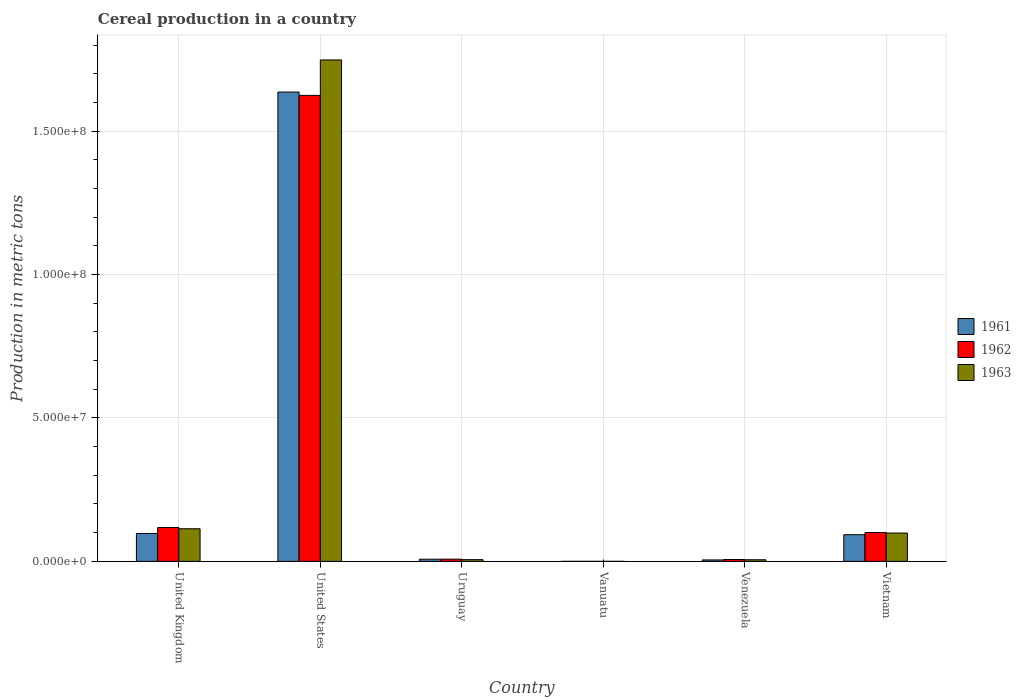How many different coloured bars are there?
Provide a short and direct response. 3. How many groups of bars are there?
Offer a very short reply. 6. Are the number of bars per tick equal to the number of legend labels?
Make the answer very short. Yes. How many bars are there on the 4th tick from the left?
Your answer should be very brief. 3. What is the label of the 3rd group of bars from the left?
Offer a terse response. Uruguay. In how many cases, is the number of bars for a given country not equal to the number of legend labels?
Give a very brief answer. 0. What is the total cereal production in 1961 in Uruguay?
Ensure brevity in your answer.  7.51e+05. Across all countries, what is the maximum total cereal production in 1961?
Keep it short and to the point. 1.64e+08. Across all countries, what is the minimum total cereal production in 1963?
Your answer should be compact. 350. In which country was the total cereal production in 1962 maximum?
Keep it short and to the point. United States. In which country was the total cereal production in 1962 minimum?
Offer a terse response. Vanuatu. What is the total total cereal production in 1961 in the graph?
Your response must be concise. 1.84e+08. What is the difference between the total cereal production in 1963 in Uruguay and that in Venezuela?
Ensure brevity in your answer.  3.44e+04. What is the difference between the total cereal production in 1961 in United Kingdom and the total cereal production in 1962 in Vietnam?
Offer a terse response. -3.39e+05. What is the average total cereal production in 1963 per country?
Keep it short and to the point. 3.29e+07. What is the difference between the total cereal production of/in 1963 and total cereal production of/in 1962 in Uruguay?
Provide a succinct answer. -1.68e+05. In how many countries, is the total cereal production in 1962 greater than 150000000 metric tons?
Provide a succinct answer. 1. What is the ratio of the total cereal production in 1963 in United Kingdom to that in Venezuela?
Provide a short and direct response. 20.21. Is the difference between the total cereal production in 1963 in United Kingdom and United States greater than the difference between the total cereal production in 1962 in United Kingdom and United States?
Offer a terse response. No. What is the difference between the highest and the second highest total cereal production in 1963?
Offer a terse response. 1.49e+06. What is the difference between the highest and the lowest total cereal production in 1963?
Your response must be concise. 1.75e+08. Are all the bars in the graph horizontal?
Offer a terse response. No. What is the difference between two consecutive major ticks on the Y-axis?
Keep it short and to the point. 5.00e+07. Are the values on the major ticks of Y-axis written in scientific E-notation?
Offer a terse response. Yes. Does the graph contain any zero values?
Provide a succinct answer. No. Does the graph contain grids?
Your response must be concise. Yes. Where does the legend appear in the graph?
Your answer should be compact. Center right. How many legend labels are there?
Ensure brevity in your answer.  3. How are the legend labels stacked?
Your answer should be compact. Vertical. What is the title of the graph?
Provide a short and direct response. Cereal production in a country. What is the label or title of the Y-axis?
Make the answer very short. Production in metric tons. What is the Production in metric tons in 1961 in United Kingdom?
Provide a short and direct response. 9.72e+06. What is the Production in metric tons in 1962 in United Kingdom?
Your response must be concise. 1.18e+07. What is the Production in metric tons of 1963 in United Kingdom?
Your answer should be very brief. 1.14e+07. What is the Production in metric tons in 1961 in United States?
Your answer should be compact. 1.64e+08. What is the Production in metric tons in 1962 in United States?
Make the answer very short. 1.62e+08. What is the Production in metric tons of 1963 in United States?
Your answer should be compact. 1.75e+08. What is the Production in metric tons in 1961 in Uruguay?
Keep it short and to the point. 7.51e+05. What is the Production in metric tons of 1962 in Uruguay?
Your answer should be very brief. 7.65e+05. What is the Production in metric tons of 1963 in Uruguay?
Your answer should be compact. 5.97e+05. What is the Production in metric tons in 1961 in Vanuatu?
Keep it short and to the point. 350. What is the Production in metric tons in 1962 in Vanuatu?
Your response must be concise. 350. What is the Production in metric tons in 1963 in Vanuatu?
Your answer should be compact. 350. What is the Production in metric tons of 1961 in Venezuela?
Ensure brevity in your answer.  5.01e+05. What is the Production in metric tons in 1962 in Venezuela?
Provide a succinct answer. 6.44e+05. What is the Production in metric tons in 1963 in Venezuela?
Provide a short and direct response. 5.62e+05. What is the Production in metric tons of 1961 in Vietnam?
Make the answer very short. 9.29e+06. What is the Production in metric tons of 1962 in Vietnam?
Give a very brief answer. 1.01e+07. What is the Production in metric tons in 1963 in Vietnam?
Make the answer very short. 9.88e+06. Across all countries, what is the maximum Production in metric tons of 1961?
Provide a short and direct response. 1.64e+08. Across all countries, what is the maximum Production in metric tons of 1962?
Keep it short and to the point. 1.62e+08. Across all countries, what is the maximum Production in metric tons of 1963?
Your response must be concise. 1.75e+08. Across all countries, what is the minimum Production in metric tons of 1961?
Ensure brevity in your answer.  350. Across all countries, what is the minimum Production in metric tons of 1962?
Your answer should be compact. 350. Across all countries, what is the minimum Production in metric tons of 1963?
Your response must be concise. 350. What is the total Production in metric tons of 1961 in the graph?
Keep it short and to the point. 1.84e+08. What is the total Production in metric tons in 1962 in the graph?
Your answer should be compact. 1.86e+08. What is the total Production in metric tons in 1963 in the graph?
Provide a short and direct response. 1.97e+08. What is the difference between the Production in metric tons of 1961 in United Kingdom and that in United States?
Your response must be concise. -1.54e+08. What is the difference between the Production in metric tons in 1962 in United Kingdom and that in United States?
Provide a short and direct response. -1.51e+08. What is the difference between the Production in metric tons of 1963 in United Kingdom and that in United States?
Your answer should be very brief. -1.63e+08. What is the difference between the Production in metric tons of 1961 in United Kingdom and that in Uruguay?
Provide a succinct answer. 8.97e+06. What is the difference between the Production in metric tons of 1962 in United Kingdom and that in Uruguay?
Offer a very short reply. 1.10e+07. What is the difference between the Production in metric tons in 1963 in United Kingdom and that in Uruguay?
Provide a succinct answer. 1.08e+07. What is the difference between the Production in metric tons in 1961 in United Kingdom and that in Vanuatu?
Your answer should be very brief. 9.72e+06. What is the difference between the Production in metric tons of 1962 in United Kingdom and that in Vanuatu?
Give a very brief answer. 1.18e+07. What is the difference between the Production in metric tons in 1963 in United Kingdom and that in Vanuatu?
Your answer should be very brief. 1.14e+07. What is the difference between the Production in metric tons in 1961 in United Kingdom and that in Venezuela?
Provide a short and direct response. 9.22e+06. What is the difference between the Production in metric tons in 1962 in United Kingdom and that in Venezuela?
Offer a very short reply. 1.11e+07. What is the difference between the Production in metric tons of 1963 in United Kingdom and that in Venezuela?
Provide a short and direct response. 1.08e+07. What is the difference between the Production in metric tons in 1961 in United Kingdom and that in Vietnam?
Keep it short and to the point. 4.32e+05. What is the difference between the Production in metric tons in 1962 in United Kingdom and that in Vietnam?
Provide a succinct answer. 1.73e+06. What is the difference between the Production in metric tons of 1963 in United Kingdom and that in Vietnam?
Offer a very short reply. 1.49e+06. What is the difference between the Production in metric tons in 1961 in United States and that in Uruguay?
Ensure brevity in your answer.  1.63e+08. What is the difference between the Production in metric tons of 1962 in United States and that in Uruguay?
Make the answer very short. 1.62e+08. What is the difference between the Production in metric tons in 1963 in United States and that in Uruguay?
Provide a succinct answer. 1.74e+08. What is the difference between the Production in metric tons in 1961 in United States and that in Vanuatu?
Keep it short and to the point. 1.64e+08. What is the difference between the Production in metric tons in 1962 in United States and that in Vanuatu?
Ensure brevity in your answer.  1.62e+08. What is the difference between the Production in metric tons in 1963 in United States and that in Vanuatu?
Your response must be concise. 1.75e+08. What is the difference between the Production in metric tons in 1961 in United States and that in Venezuela?
Your response must be concise. 1.63e+08. What is the difference between the Production in metric tons in 1962 in United States and that in Venezuela?
Provide a succinct answer. 1.62e+08. What is the difference between the Production in metric tons in 1963 in United States and that in Venezuela?
Your response must be concise. 1.74e+08. What is the difference between the Production in metric tons in 1961 in United States and that in Vietnam?
Your answer should be compact. 1.54e+08. What is the difference between the Production in metric tons of 1962 in United States and that in Vietnam?
Give a very brief answer. 1.52e+08. What is the difference between the Production in metric tons of 1963 in United States and that in Vietnam?
Your answer should be very brief. 1.65e+08. What is the difference between the Production in metric tons of 1961 in Uruguay and that in Vanuatu?
Provide a short and direct response. 7.51e+05. What is the difference between the Production in metric tons of 1962 in Uruguay and that in Vanuatu?
Give a very brief answer. 7.64e+05. What is the difference between the Production in metric tons in 1963 in Uruguay and that in Vanuatu?
Ensure brevity in your answer.  5.96e+05. What is the difference between the Production in metric tons in 1961 in Uruguay and that in Venezuela?
Offer a very short reply. 2.50e+05. What is the difference between the Production in metric tons in 1962 in Uruguay and that in Venezuela?
Provide a short and direct response. 1.20e+05. What is the difference between the Production in metric tons of 1963 in Uruguay and that in Venezuela?
Your answer should be compact. 3.44e+04. What is the difference between the Production in metric tons of 1961 in Uruguay and that in Vietnam?
Provide a short and direct response. -8.54e+06. What is the difference between the Production in metric tons of 1962 in Uruguay and that in Vietnam?
Make the answer very short. -9.30e+06. What is the difference between the Production in metric tons of 1963 in Uruguay and that in Vietnam?
Offer a very short reply. -9.28e+06. What is the difference between the Production in metric tons in 1961 in Vanuatu and that in Venezuela?
Give a very brief answer. -5.01e+05. What is the difference between the Production in metric tons of 1962 in Vanuatu and that in Venezuela?
Your answer should be compact. -6.44e+05. What is the difference between the Production in metric tons in 1963 in Vanuatu and that in Venezuela?
Provide a succinct answer. -5.62e+05. What is the difference between the Production in metric tons in 1961 in Vanuatu and that in Vietnam?
Your response must be concise. -9.29e+06. What is the difference between the Production in metric tons of 1962 in Vanuatu and that in Vietnam?
Provide a succinct answer. -1.01e+07. What is the difference between the Production in metric tons in 1963 in Vanuatu and that in Vietnam?
Offer a very short reply. -9.88e+06. What is the difference between the Production in metric tons of 1961 in Venezuela and that in Vietnam?
Keep it short and to the point. -8.79e+06. What is the difference between the Production in metric tons of 1962 in Venezuela and that in Vietnam?
Make the answer very short. -9.42e+06. What is the difference between the Production in metric tons of 1963 in Venezuela and that in Vietnam?
Your response must be concise. -9.31e+06. What is the difference between the Production in metric tons in 1961 in United Kingdom and the Production in metric tons in 1962 in United States?
Make the answer very short. -1.53e+08. What is the difference between the Production in metric tons of 1961 in United Kingdom and the Production in metric tons of 1963 in United States?
Your answer should be compact. -1.65e+08. What is the difference between the Production in metric tons in 1962 in United Kingdom and the Production in metric tons in 1963 in United States?
Ensure brevity in your answer.  -1.63e+08. What is the difference between the Production in metric tons in 1961 in United Kingdom and the Production in metric tons in 1962 in Uruguay?
Offer a very short reply. 8.96e+06. What is the difference between the Production in metric tons in 1961 in United Kingdom and the Production in metric tons in 1963 in Uruguay?
Offer a very short reply. 9.13e+06. What is the difference between the Production in metric tons in 1962 in United Kingdom and the Production in metric tons in 1963 in Uruguay?
Give a very brief answer. 1.12e+07. What is the difference between the Production in metric tons of 1961 in United Kingdom and the Production in metric tons of 1962 in Vanuatu?
Your response must be concise. 9.72e+06. What is the difference between the Production in metric tons in 1961 in United Kingdom and the Production in metric tons in 1963 in Vanuatu?
Ensure brevity in your answer.  9.72e+06. What is the difference between the Production in metric tons of 1962 in United Kingdom and the Production in metric tons of 1963 in Vanuatu?
Your answer should be very brief. 1.18e+07. What is the difference between the Production in metric tons in 1961 in United Kingdom and the Production in metric tons in 1962 in Venezuela?
Ensure brevity in your answer.  9.08e+06. What is the difference between the Production in metric tons of 1961 in United Kingdom and the Production in metric tons of 1963 in Venezuela?
Offer a terse response. 9.16e+06. What is the difference between the Production in metric tons in 1962 in United Kingdom and the Production in metric tons in 1963 in Venezuela?
Keep it short and to the point. 1.12e+07. What is the difference between the Production in metric tons in 1961 in United Kingdom and the Production in metric tons in 1962 in Vietnam?
Provide a short and direct response. -3.39e+05. What is the difference between the Production in metric tons in 1961 in United Kingdom and the Production in metric tons in 1963 in Vietnam?
Give a very brief answer. -1.55e+05. What is the difference between the Production in metric tons in 1962 in United Kingdom and the Production in metric tons in 1963 in Vietnam?
Give a very brief answer. 1.91e+06. What is the difference between the Production in metric tons in 1961 in United States and the Production in metric tons in 1962 in Uruguay?
Provide a succinct answer. 1.63e+08. What is the difference between the Production in metric tons in 1961 in United States and the Production in metric tons in 1963 in Uruguay?
Make the answer very short. 1.63e+08. What is the difference between the Production in metric tons of 1962 in United States and the Production in metric tons of 1963 in Uruguay?
Offer a terse response. 1.62e+08. What is the difference between the Production in metric tons in 1961 in United States and the Production in metric tons in 1962 in Vanuatu?
Provide a short and direct response. 1.64e+08. What is the difference between the Production in metric tons in 1961 in United States and the Production in metric tons in 1963 in Vanuatu?
Provide a short and direct response. 1.64e+08. What is the difference between the Production in metric tons in 1962 in United States and the Production in metric tons in 1963 in Vanuatu?
Make the answer very short. 1.62e+08. What is the difference between the Production in metric tons in 1961 in United States and the Production in metric tons in 1962 in Venezuela?
Make the answer very short. 1.63e+08. What is the difference between the Production in metric tons in 1961 in United States and the Production in metric tons in 1963 in Venezuela?
Your response must be concise. 1.63e+08. What is the difference between the Production in metric tons of 1962 in United States and the Production in metric tons of 1963 in Venezuela?
Give a very brief answer. 1.62e+08. What is the difference between the Production in metric tons of 1961 in United States and the Production in metric tons of 1962 in Vietnam?
Offer a very short reply. 1.54e+08. What is the difference between the Production in metric tons in 1961 in United States and the Production in metric tons in 1963 in Vietnam?
Your response must be concise. 1.54e+08. What is the difference between the Production in metric tons of 1962 in United States and the Production in metric tons of 1963 in Vietnam?
Make the answer very short. 1.53e+08. What is the difference between the Production in metric tons in 1961 in Uruguay and the Production in metric tons in 1962 in Vanuatu?
Your answer should be compact. 7.51e+05. What is the difference between the Production in metric tons of 1961 in Uruguay and the Production in metric tons of 1963 in Vanuatu?
Your answer should be very brief. 7.51e+05. What is the difference between the Production in metric tons in 1962 in Uruguay and the Production in metric tons in 1963 in Vanuatu?
Your answer should be compact. 7.64e+05. What is the difference between the Production in metric tons in 1961 in Uruguay and the Production in metric tons in 1962 in Venezuela?
Make the answer very short. 1.07e+05. What is the difference between the Production in metric tons of 1961 in Uruguay and the Production in metric tons of 1963 in Venezuela?
Offer a terse response. 1.89e+05. What is the difference between the Production in metric tons in 1962 in Uruguay and the Production in metric tons in 1963 in Venezuela?
Offer a very short reply. 2.02e+05. What is the difference between the Production in metric tons of 1961 in Uruguay and the Production in metric tons of 1962 in Vietnam?
Offer a terse response. -9.31e+06. What is the difference between the Production in metric tons of 1961 in Uruguay and the Production in metric tons of 1963 in Vietnam?
Keep it short and to the point. -9.13e+06. What is the difference between the Production in metric tons of 1962 in Uruguay and the Production in metric tons of 1963 in Vietnam?
Make the answer very short. -9.11e+06. What is the difference between the Production in metric tons in 1961 in Vanuatu and the Production in metric tons in 1962 in Venezuela?
Offer a very short reply. -6.44e+05. What is the difference between the Production in metric tons in 1961 in Vanuatu and the Production in metric tons in 1963 in Venezuela?
Offer a very short reply. -5.62e+05. What is the difference between the Production in metric tons in 1962 in Vanuatu and the Production in metric tons in 1963 in Venezuela?
Ensure brevity in your answer.  -5.62e+05. What is the difference between the Production in metric tons of 1961 in Vanuatu and the Production in metric tons of 1962 in Vietnam?
Offer a terse response. -1.01e+07. What is the difference between the Production in metric tons of 1961 in Vanuatu and the Production in metric tons of 1963 in Vietnam?
Offer a terse response. -9.88e+06. What is the difference between the Production in metric tons of 1962 in Vanuatu and the Production in metric tons of 1963 in Vietnam?
Your response must be concise. -9.88e+06. What is the difference between the Production in metric tons in 1961 in Venezuela and the Production in metric tons in 1962 in Vietnam?
Ensure brevity in your answer.  -9.56e+06. What is the difference between the Production in metric tons of 1961 in Venezuela and the Production in metric tons of 1963 in Vietnam?
Your answer should be very brief. -9.38e+06. What is the difference between the Production in metric tons in 1962 in Venezuela and the Production in metric tons in 1963 in Vietnam?
Your answer should be very brief. -9.23e+06. What is the average Production in metric tons in 1961 per country?
Your answer should be compact. 3.06e+07. What is the average Production in metric tons of 1962 per country?
Your answer should be very brief. 3.10e+07. What is the average Production in metric tons in 1963 per country?
Provide a succinct answer. 3.29e+07. What is the difference between the Production in metric tons of 1961 and Production in metric tons of 1962 in United Kingdom?
Offer a very short reply. -2.07e+06. What is the difference between the Production in metric tons of 1961 and Production in metric tons of 1963 in United Kingdom?
Your response must be concise. -1.64e+06. What is the difference between the Production in metric tons of 1962 and Production in metric tons of 1963 in United Kingdom?
Your response must be concise. 4.26e+05. What is the difference between the Production in metric tons of 1961 and Production in metric tons of 1962 in United States?
Provide a short and direct response. 1.16e+06. What is the difference between the Production in metric tons of 1961 and Production in metric tons of 1963 in United States?
Provide a short and direct response. -1.12e+07. What is the difference between the Production in metric tons of 1962 and Production in metric tons of 1963 in United States?
Your answer should be very brief. -1.24e+07. What is the difference between the Production in metric tons in 1961 and Production in metric tons in 1962 in Uruguay?
Your response must be concise. -1.37e+04. What is the difference between the Production in metric tons of 1961 and Production in metric tons of 1963 in Uruguay?
Your response must be concise. 1.54e+05. What is the difference between the Production in metric tons of 1962 and Production in metric tons of 1963 in Uruguay?
Provide a succinct answer. 1.68e+05. What is the difference between the Production in metric tons in 1961 and Production in metric tons in 1963 in Vanuatu?
Ensure brevity in your answer.  0. What is the difference between the Production in metric tons of 1961 and Production in metric tons of 1962 in Venezuela?
Offer a terse response. -1.43e+05. What is the difference between the Production in metric tons in 1961 and Production in metric tons in 1963 in Venezuela?
Provide a succinct answer. -6.10e+04. What is the difference between the Production in metric tons in 1962 and Production in metric tons in 1963 in Venezuela?
Offer a very short reply. 8.18e+04. What is the difference between the Production in metric tons of 1961 and Production in metric tons of 1962 in Vietnam?
Give a very brief answer. -7.72e+05. What is the difference between the Production in metric tons in 1961 and Production in metric tons in 1963 in Vietnam?
Keep it short and to the point. -5.87e+05. What is the difference between the Production in metric tons of 1962 and Production in metric tons of 1963 in Vietnam?
Offer a terse response. 1.85e+05. What is the ratio of the Production in metric tons of 1961 in United Kingdom to that in United States?
Your answer should be compact. 0.06. What is the ratio of the Production in metric tons in 1962 in United Kingdom to that in United States?
Offer a very short reply. 0.07. What is the ratio of the Production in metric tons of 1963 in United Kingdom to that in United States?
Keep it short and to the point. 0.07. What is the ratio of the Production in metric tons in 1961 in United Kingdom to that in Uruguay?
Your answer should be compact. 12.95. What is the ratio of the Production in metric tons of 1962 in United Kingdom to that in Uruguay?
Make the answer very short. 15.42. What is the ratio of the Production in metric tons in 1963 in United Kingdom to that in Uruguay?
Your answer should be compact. 19.04. What is the ratio of the Production in metric tons of 1961 in United Kingdom to that in Vanuatu?
Provide a short and direct response. 2.78e+04. What is the ratio of the Production in metric tons in 1962 in United Kingdom to that in Vanuatu?
Offer a terse response. 3.37e+04. What is the ratio of the Production in metric tons of 1963 in United Kingdom to that in Vanuatu?
Offer a very short reply. 3.25e+04. What is the ratio of the Production in metric tons in 1961 in United Kingdom to that in Venezuela?
Make the answer very short. 19.39. What is the ratio of the Production in metric tons of 1962 in United Kingdom to that in Venezuela?
Your answer should be compact. 18.3. What is the ratio of the Production in metric tons in 1963 in United Kingdom to that in Venezuela?
Ensure brevity in your answer.  20.21. What is the ratio of the Production in metric tons in 1961 in United Kingdom to that in Vietnam?
Keep it short and to the point. 1.05. What is the ratio of the Production in metric tons of 1962 in United Kingdom to that in Vietnam?
Provide a succinct answer. 1.17. What is the ratio of the Production in metric tons of 1963 in United Kingdom to that in Vietnam?
Provide a succinct answer. 1.15. What is the ratio of the Production in metric tons of 1961 in United States to that in Uruguay?
Your answer should be compact. 217.89. What is the ratio of the Production in metric tons in 1962 in United States to that in Uruguay?
Give a very brief answer. 212.46. What is the ratio of the Production in metric tons of 1963 in United States to that in Uruguay?
Make the answer very short. 292.92. What is the ratio of the Production in metric tons of 1961 in United States to that in Vanuatu?
Provide a succinct answer. 4.67e+05. What is the ratio of the Production in metric tons of 1962 in United States to that in Vanuatu?
Offer a terse response. 4.64e+05. What is the ratio of the Production in metric tons of 1963 in United States to that in Vanuatu?
Ensure brevity in your answer.  4.99e+05. What is the ratio of the Production in metric tons of 1961 in United States to that in Venezuela?
Keep it short and to the point. 326.33. What is the ratio of the Production in metric tons of 1962 in United States to that in Venezuela?
Your answer should be very brief. 252.17. What is the ratio of the Production in metric tons of 1963 in United States to that in Venezuela?
Make the answer very short. 310.84. What is the ratio of the Production in metric tons of 1961 in United States to that in Vietnam?
Offer a very short reply. 17.61. What is the ratio of the Production in metric tons of 1962 in United States to that in Vietnam?
Ensure brevity in your answer.  16.15. What is the ratio of the Production in metric tons of 1963 in United States to that in Vietnam?
Provide a succinct answer. 17.7. What is the ratio of the Production in metric tons of 1961 in Uruguay to that in Vanuatu?
Your answer should be compact. 2145.5. What is the ratio of the Production in metric tons of 1962 in Uruguay to that in Vanuatu?
Give a very brief answer. 2184.7. What is the ratio of the Production in metric tons in 1963 in Uruguay to that in Vanuatu?
Give a very brief answer. 1705.1. What is the ratio of the Production in metric tons of 1961 in Uruguay to that in Venezuela?
Ensure brevity in your answer.  1.5. What is the ratio of the Production in metric tons in 1962 in Uruguay to that in Venezuela?
Make the answer very short. 1.19. What is the ratio of the Production in metric tons of 1963 in Uruguay to that in Venezuela?
Make the answer very short. 1.06. What is the ratio of the Production in metric tons of 1961 in Uruguay to that in Vietnam?
Your answer should be very brief. 0.08. What is the ratio of the Production in metric tons of 1962 in Uruguay to that in Vietnam?
Provide a succinct answer. 0.08. What is the ratio of the Production in metric tons in 1963 in Uruguay to that in Vietnam?
Provide a short and direct response. 0.06. What is the ratio of the Production in metric tons of 1961 in Vanuatu to that in Venezuela?
Your answer should be compact. 0. What is the ratio of the Production in metric tons of 1962 in Vanuatu to that in Venezuela?
Provide a short and direct response. 0. What is the ratio of the Production in metric tons in 1963 in Vanuatu to that in Venezuela?
Give a very brief answer. 0. What is the ratio of the Production in metric tons in 1962 in Vanuatu to that in Vietnam?
Make the answer very short. 0. What is the ratio of the Production in metric tons of 1961 in Venezuela to that in Vietnam?
Make the answer very short. 0.05. What is the ratio of the Production in metric tons in 1962 in Venezuela to that in Vietnam?
Keep it short and to the point. 0.06. What is the ratio of the Production in metric tons in 1963 in Venezuela to that in Vietnam?
Offer a terse response. 0.06. What is the difference between the highest and the second highest Production in metric tons of 1961?
Your response must be concise. 1.54e+08. What is the difference between the highest and the second highest Production in metric tons in 1962?
Offer a very short reply. 1.51e+08. What is the difference between the highest and the second highest Production in metric tons in 1963?
Offer a very short reply. 1.63e+08. What is the difference between the highest and the lowest Production in metric tons of 1961?
Your response must be concise. 1.64e+08. What is the difference between the highest and the lowest Production in metric tons in 1962?
Keep it short and to the point. 1.62e+08. What is the difference between the highest and the lowest Production in metric tons of 1963?
Provide a short and direct response. 1.75e+08. 